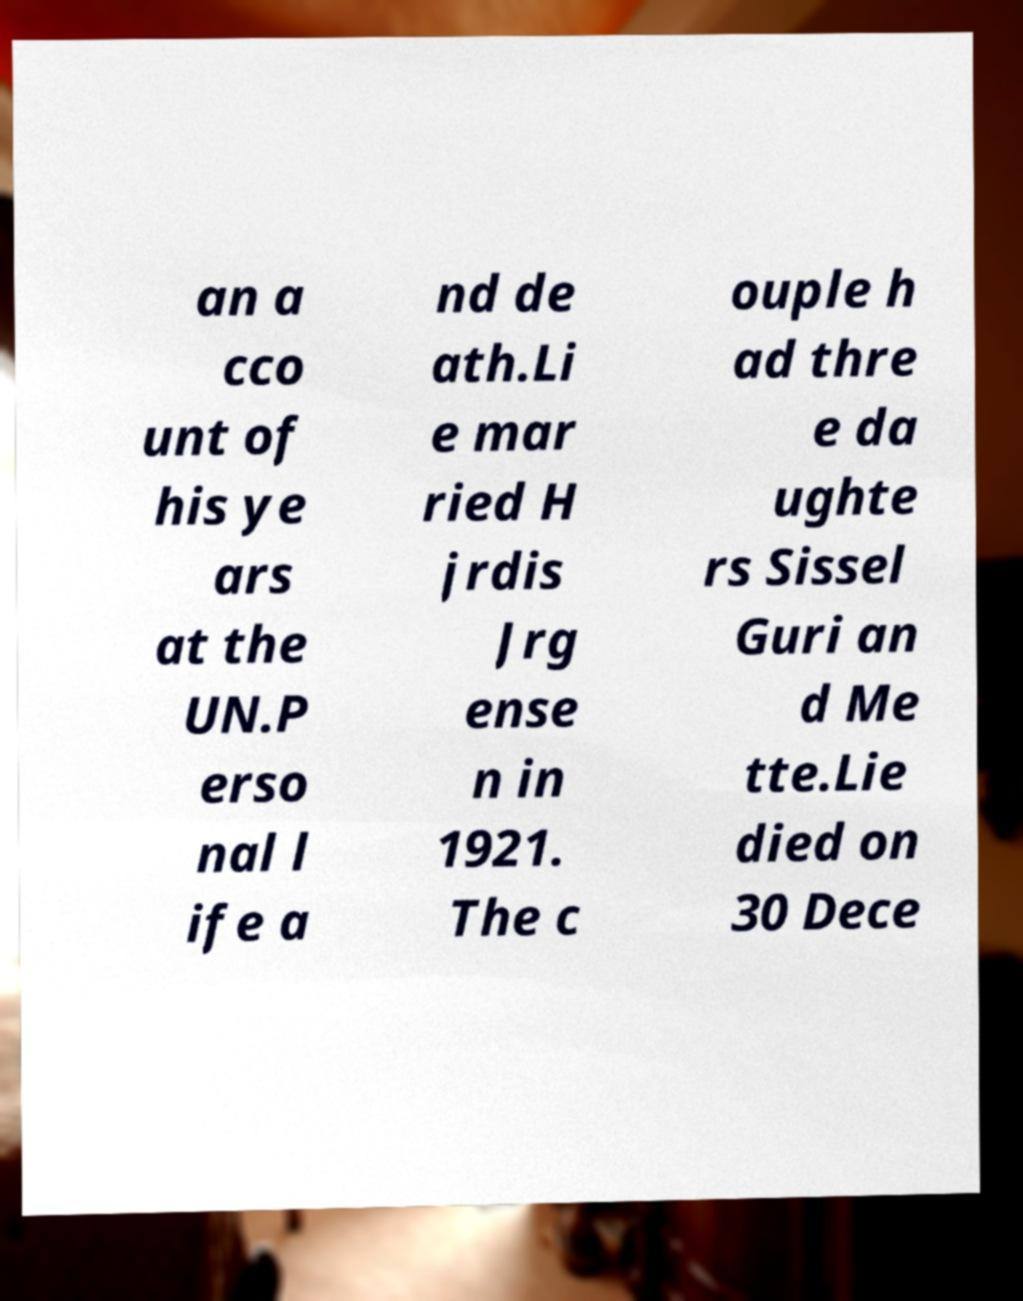For documentation purposes, I need the text within this image transcribed. Could you provide that? an a cco unt of his ye ars at the UN.P erso nal l ife a nd de ath.Li e mar ried H jrdis Jrg ense n in 1921. The c ouple h ad thre e da ughte rs Sissel Guri an d Me tte.Lie died on 30 Dece 